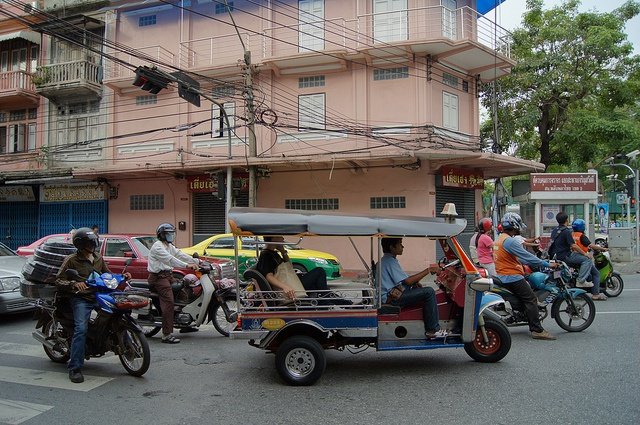Describe the objects in this image and their specific colors. I can see motorcycle in gray, black, darkgray, and navy tones, motorcycle in gray, black, darkgray, and maroon tones, people in gray, black, maroon, and blue tones, motorcycle in gray, black, and blue tones, and people in gray, black, navy, and blue tones in this image. 